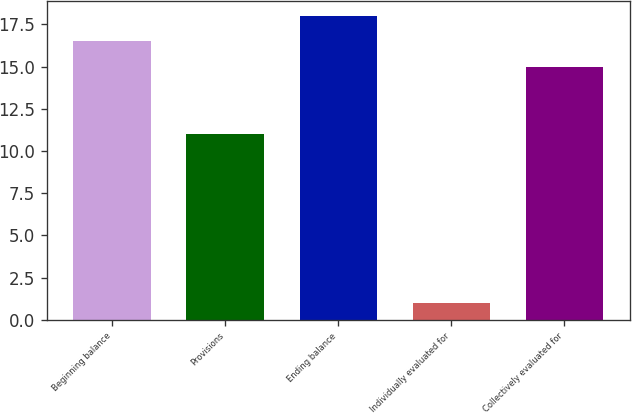<chart> <loc_0><loc_0><loc_500><loc_500><bar_chart><fcel>Beginning balance<fcel>Provisions<fcel>Ending balance<fcel>Individually evaluated for<fcel>Collectively evaluated for<nl><fcel>16.5<fcel>11<fcel>18<fcel>1<fcel>15<nl></chart> 